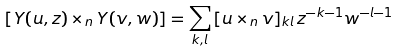<formula> <loc_0><loc_0><loc_500><loc_500>[ Y ( u , z ) \times _ { n } Y ( v , w ) ] = \sum _ { k , l } \, [ u \times _ { n } v ] _ { k l } \, z ^ { - k - 1 } w ^ { - l - 1 }</formula> 